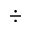<formula> <loc_0><loc_0><loc_500><loc_500>\div</formula> 